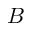Convert formula to latex. <formula><loc_0><loc_0><loc_500><loc_500>B</formula> 